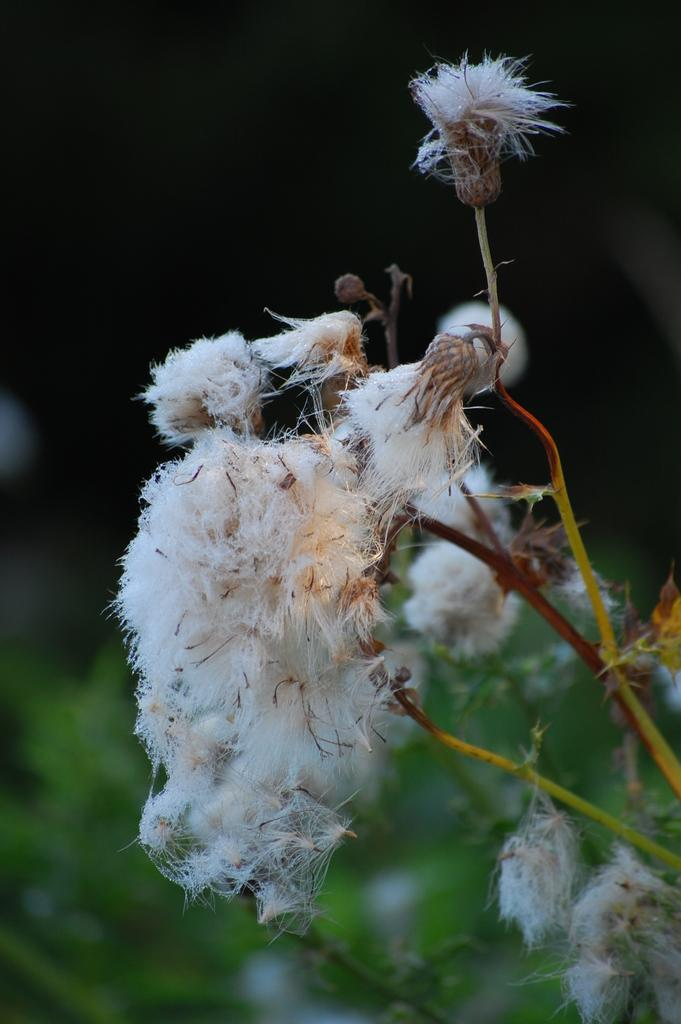What type of living organisms can be seen in the image? There are flowers in the image. Where are the flowers located? The flowers are grown on a plant. Can you describe the background of the image? The background of the image is blurred. What type of wool can be seen on the edge of the flowers in the image? There is no wool present in the image, and the flowers do not have an edge. 